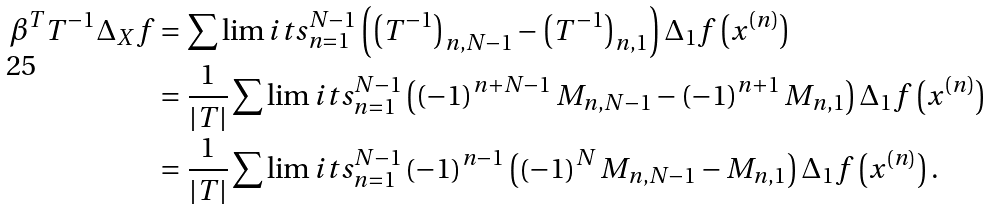Convert formula to latex. <formula><loc_0><loc_0><loc_500><loc_500>\beta ^ { T } T ^ { - 1 } \Delta _ { X } f & = \sum \lim i t s _ { n = 1 } ^ { N - 1 } \left ( \left ( T ^ { - 1 } \right ) _ { n , N - 1 } - \left ( T ^ { - 1 } \right ) _ { n , 1 } \right ) \Delta _ { 1 } f \left ( x ^ { \left ( n \right ) } \right ) \\ & = \frac { 1 } { \left | T \right | } \sum \lim i t s _ { n = 1 } ^ { N - 1 } \left ( \left ( - 1 \right ) ^ { n + N - 1 } M _ { n , N - 1 } - \left ( - 1 \right ) ^ { n + 1 } M _ { n , 1 } \right ) \Delta _ { 1 } f \left ( x ^ { \left ( n \right ) } \right ) \\ & = \frac { 1 } { \left | T \right | } \sum \lim i t s _ { n = 1 } ^ { N - 1 } \left ( - 1 \right ) ^ { n - 1 } \left ( \left ( - 1 \right ) ^ { N } M _ { n , N - 1 } - M _ { n , 1 } \right ) \Delta _ { 1 } f \left ( x ^ { \left ( n \right ) } \right ) .</formula> 